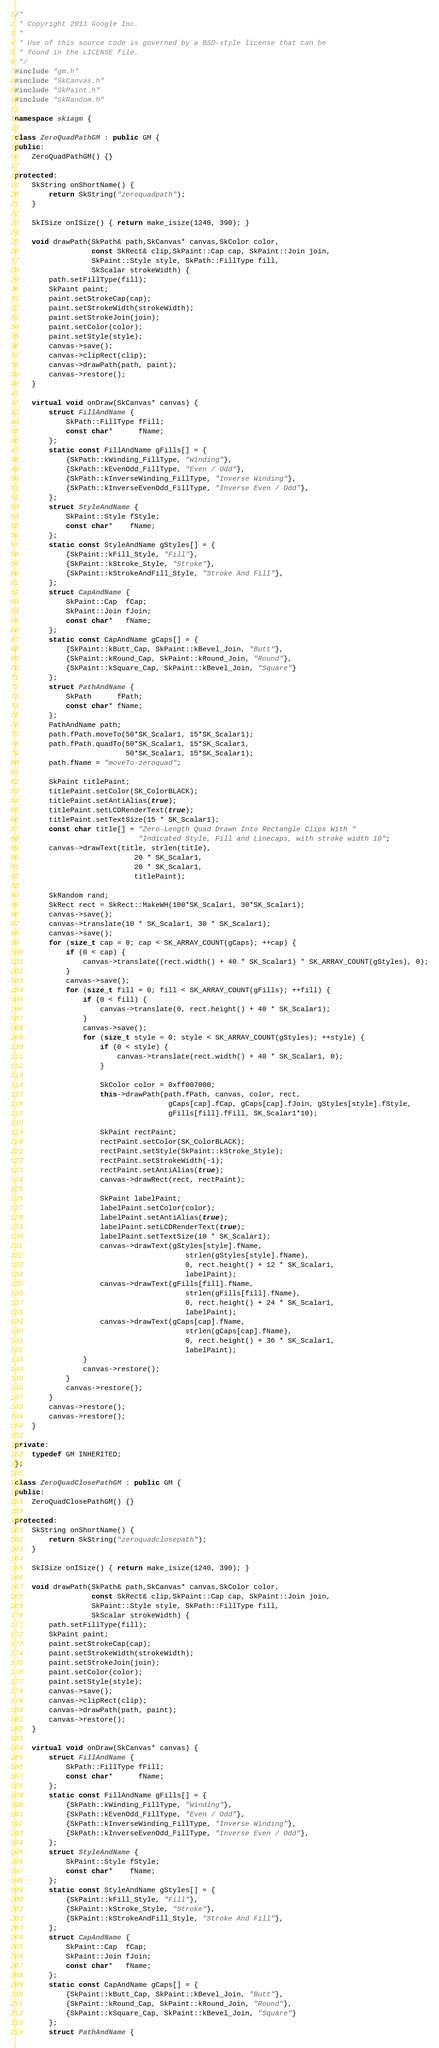<code> <loc_0><loc_0><loc_500><loc_500><_C++_>/*
 * Copyright 2011 Google Inc.
 *
 * Use of this source code is governed by a BSD-style license that can be
 * found in the LICENSE file.
 */
#include "gm.h"
#include "SkCanvas.h"
#include "SkPaint.h"
#include "SkRandom.h"

namespace skiagm {

class ZeroQuadPathGM : public GM {
public:
    ZeroQuadPathGM() {}

protected:
    SkString onShortName() {
        return SkString("zeroquadpath");
    }
        
    SkISize onISize() { return make_isize(1240, 390); }
    
    void drawPath(SkPath& path,SkCanvas* canvas,SkColor color,
                  const SkRect& clip,SkPaint::Cap cap, SkPaint::Join join,
                  SkPaint::Style style, SkPath::FillType fill,
                  SkScalar strokeWidth) {
        path.setFillType(fill);
        SkPaint paint;
        paint.setStrokeCap(cap);
        paint.setStrokeWidth(strokeWidth);
        paint.setStrokeJoin(join);
        paint.setColor(color);
        paint.setStyle(style);
        canvas->save();
        canvas->clipRect(clip);
        canvas->drawPath(path, paint);
        canvas->restore();
    }
    
    virtual void onDraw(SkCanvas* canvas) {
        struct FillAndName {
            SkPath::FillType fFill;
            const char*      fName;
        };
        static const FillAndName gFills[] = {
            {SkPath::kWinding_FillType, "Winding"},
            {SkPath::kEvenOdd_FillType, "Even / Odd"},
            {SkPath::kInverseWinding_FillType, "Inverse Winding"},
            {SkPath::kInverseEvenOdd_FillType, "Inverse Even / Odd"},
        };
        struct StyleAndName {
            SkPaint::Style fStyle;
            const char*    fName;
        };
        static const StyleAndName gStyles[] = {
            {SkPaint::kFill_Style, "Fill"},
            {SkPaint::kStroke_Style, "Stroke"},
            {SkPaint::kStrokeAndFill_Style, "Stroke And Fill"},
        };
        struct CapAndName {
            SkPaint::Cap  fCap;
            SkPaint::Join fJoin;
            const char*   fName;
        };
        static const CapAndName gCaps[] = {
            {SkPaint::kButt_Cap, SkPaint::kBevel_Join, "Butt"},
            {SkPaint::kRound_Cap, SkPaint::kRound_Join, "Round"},
            {SkPaint::kSquare_Cap, SkPaint::kBevel_Join, "Square"}
        };
        struct PathAndName {
            SkPath      fPath;
            const char* fName;
        };
        PathAndName path;
        path.fPath.moveTo(50*SK_Scalar1, 15*SK_Scalar1);
        path.fPath.quadTo(50*SK_Scalar1, 15*SK_Scalar1,
                          50*SK_Scalar1, 15*SK_Scalar1);
        path.fName = "moveTo-zeroquad";

        SkPaint titlePaint;
        titlePaint.setColor(SK_ColorBLACK);
        titlePaint.setAntiAlias(true);
        titlePaint.setLCDRenderText(true);
        titlePaint.setTextSize(15 * SK_Scalar1);
        const char title[] = "Zero-Length Quad Drawn Into Rectangle Clips With "
                             "Indicated Style, Fill and Linecaps, with stroke width 10";
        canvas->drawText(title, strlen(title),
                            20 * SK_Scalar1,
                            20 * SK_Scalar1,
                            titlePaint);

        SkRandom rand;
        SkRect rect = SkRect::MakeWH(100*SK_Scalar1, 30*SK_Scalar1);
        canvas->save();
        canvas->translate(10 * SK_Scalar1, 30 * SK_Scalar1);
        canvas->save();
        for (size_t cap = 0; cap < SK_ARRAY_COUNT(gCaps); ++cap) {
            if (0 < cap) {
                canvas->translate((rect.width() + 40 * SK_Scalar1) * SK_ARRAY_COUNT(gStyles), 0);
            }
            canvas->save();
            for (size_t fill = 0; fill < SK_ARRAY_COUNT(gFills); ++fill) {
                if (0 < fill) {
                    canvas->translate(0, rect.height() + 40 * SK_Scalar1);
                }
                canvas->save();
                for (size_t style = 0; style < SK_ARRAY_COUNT(gStyles); ++style) {
                    if (0 < style) {
                        canvas->translate(rect.width() + 40 * SK_Scalar1, 0);
                    }
        
                    SkColor color = 0xff007000;
                    this->drawPath(path.fPath, canvas, color, rect,
                                    gCaps[cap].fCap, gCaps[cap].fJoin, gStyles[style].fStyle,
                                    gFills[fill].fFill, SK_Scalar1*10);
        
                    SkPaint rectPaint;
                    rectPaint.setColor(SK_ColorBLACK);
                    rectPaint.setStyle(SkPaint::kStroke_Style);
                    rectPaint.setStrokeWidth(-1);
                    rectPaint.setAntiAlias(true);
                    canvas->drawRect(rect, rectPaint);
        
                    SkPaint labelPaint;
                    labelPaint.setColor(color);
                    labelPaint.setAntiAlias(true);
                    labelPaint.setLCDRenderText(true);
                    labelPaint.setTextSize(10 * SK_Scalar1);
                    canvas->drawText(gStyles[style].fName,
                                        strlen(gStyles[style].fName),
                                        0, rect.height() + 12 * SK_Scalar1,
                                        labelPaint);
                    canvas->drawText(gFills[fill].fName,
                                        strlen(gFills[fill].fName),
                                        0, rect.height() + 24 * SK_Scalar1,
                                        labelPaint);
                    canvas->drawText(gCaps[cap].fName,
                                        strlen(gCaps[cap].fName),
                                        0, rect.height() + 36 * SK_Scalar1,
                                        labelPaint);
                }
                canvas->restore();
            }
            canvas->restore();
        }
        canvas->restore();
        canvas->restore();
    }
    
private:
    typedef GM INHERITED;
};

class ZeroQuadClosePathGM : public GM {
public:
    ZeroQuadClosePathGM() {}

protected:
    SkString onShortName() {
        return SkString("zeroquadclosepath");
    }
        
    SkISize onISize() { return make_isize(1240, 390); }
    
    void drawPath(SkPath& path,SkCanvas* canvas,SkColor color,
                  const SkRect& clip,SkPaint::Cap cap, SkPaint::Join join,
                  SkPaint::Style style, SkPath::FillType fill,
                  SkScalar strokeWidth) {
        path.setFillType(fill);
        SkPaint paint;
        paint.setStrokeCap(cap);
        paint.setStrokeWidth(strokeWidth);
        paint.setStrokeJoin(join);
        paint.setColor(color);
        paint.setStyle(style);
        canvas->save();
        canvas->clipRect(clip);
        canvas->drawPath(path, paint);
        canvas->restore();
    }
    
    virtual void onDraw(SkCanvas* canvas) {
        struct FillAndName {
            SkPath::FillType fFill;
            const char*      fName;
        };
        static const FillAndName gFills[] = {
            {SkPath::kWinding_FillType, "Winding"},
            {SkPath::kEvenOdd_FillType, "Even / Odd"},
            {SkPath::kInverseWinding_FillType, "Inverse Winding"},
            {SkPath::kInverseEvenOdd_FillType, "Inverse Even / Odd"},
        };
        struct StyleAndName {
            SkPaint::Style fStyle;
            const char*    fName;
        };
        static const StyleAndName gStyles[] = {
            {SkPaint::kFill_Style, "Fill"},
            {SkPaint::kStroke_Style, "Stroke"},
            {SkPaint::kStrokeAndFill_Style, "Stroke And Fill"},
        };
        struct CapAndName {
            SkPaint::Cap  fCap;
            SkPaint::Join fJoin;
            const char*   fName;
        };
        static const CapAndName gCaps[] = {
            {SkPaint::kButt_Cap, SkPaint::kBevel_Join, "Butt"},
            {SkPaint::kRound_Cap, SkPaint::kRound_Join, "Round"},
            {SkPaint::kSquare_Cap, SkPaint::kBevel_Join, "Square"}
        };
        struct PathAndName {</code> 